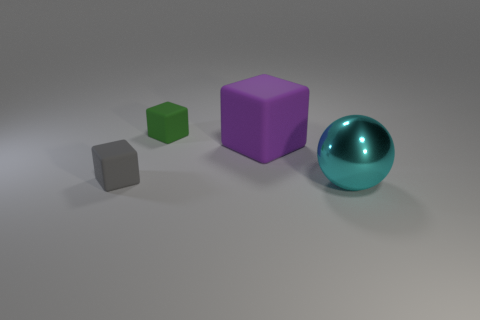Is there anything else that has the same material as the large cyan object?
Your answer should be very brief. No. How many green metallic spheres are there?
Your response must be concise. 0. What number of small objects are either blue shiny objects or cyan balls?
Keep it short and to the point. 0. There is a rubber thing that is the same size as the shiny ball; what shape is it?
Your answer should be very brief. Cube. There is a big cyan thing that is right of the tiny matte cube behind the large matte object; what is it made of?
Offer a terse response. Metal. Do the purple block and the cyan thing have the same size?
Your response must be concise. Yes. How many things are tiny matte things that are in front of the purple rubber cube or large matte objects?
Your response must be concise. 2. The big thing that is in front of the big object that is to the left of the metal object is what shape?
Provide a succinct answer. Sphere. There is a gray block; is its size the same as the cube on the right side of the green rubber thing?
Make the answer very short. No. There is a green block that is left of the big purple object; what is it made of?
Your response must be concise. Rubber. 